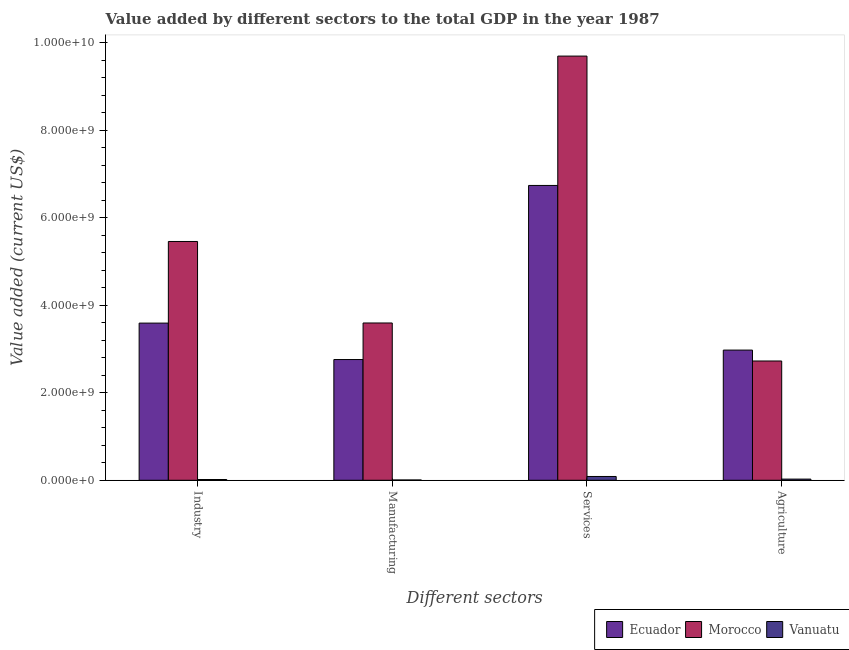How many different coloured bars are there?
Give a very brief answer. 3. How many groups of bars are there?
Keep it short and to the point. 4. Are the number of bars per tick equal to the number of legend labels?
Make the answer very short. Yes. How many bars are there on the 3rd tick from the right?
Keep it short and to the point. 3. What is the label of the 4th group of bars from the left?
Provide a succinct answer. Agriculture. What is the value added by agricultural sector in Vanuatu?
Give a very brief answer. 2.66e+07. Across all countries, what is the maximum value added by agricultural sector?
Provide a short and direct response. 2.98e+09. Across all countries, what is the minimum value added by manufacturing sector?
Make the answer very short. 6.66e+06. In which country was the value added by manufacturing sector maximum?
Provide a succinct answer. Morocco. In which country was the value added by services sector minimum?
Provide a short and direct response. Vanuatu. What is the total value added by manufacturing sector in the graph?
Offer a very short reply. 6.36e+09. What is the difference between the value added by industrial sector in Vanuatu and that in Ecuador?
Offer a terse response. -3.58e+09. What is the difference between the value added by manufacturing sector in Vanuatu and the value added by services sector in Ecuador?
Give a very brief answer. -6.74e+09. What is the average value added by services sector per country?
Your answer should be very brief. 5.51e+09. What is the difference between the value added by services sector and value added by manufacturing sector in Vanuatu?
Ensure brevity in your answer.  8.01e+07. What is the ratio of the value added by agricultural sector in Morocco to that in Vanuatu?
Your response must be concise. 102.37. Is the value added by services sector in Vanuatu less than that in Morocco?
Make the answer very short. Yes. What is the difference between the highest and the second highest value added by agricultural sector?
Ensure brevity in your answer.  2.49e+08. What is the difference between the highest and the lowest value added by agricultural sector?
Provide a succinct answer. 2.95e+09. In how many countries, is the value added by industrial sector greater than the average value added by industrial sector taken over all countries?
Your answer should be very brief. 2. Is the sum of the value added by services sector in Ecuador and Morocco greater than the maximum value added by manufacturing sector across all countries?
Your answer should be compact. Yes. Is it the case that in every country, the sum of the value added by services sector and value added by industrial sector is greater than the sum of value added by manufacturing sector and value added by agricultural sector?
Give a very brief answer. No. What does the 1st bar from the left in Services represents?
Make the answer very short. Ecuador. What does the 3rd bar from the right in Industry represents?
Your answer should be compact. Ecuador. How many bars are there?
Keep it short and to the point. 12. Are all the bars in the graph horizontal?
Your response must be concise. No. What is the difference between two consecutive major ticks on the Y-axis?
Offer a very short reply. 2.00e+09. Are the values on the major ticks of Y-axis written in scientific E-notation?
Your answer should be very brief. Yes. Where does the legend appear in the graph?
Give a very brief answer. Bottom right. How many legend labels are there?
Your answer should be very brief. 3. What is the title of the graph?
Make the answer very short. Value added by different sectors to the total GDP in the year 1987. What is the label or title of the X-axis?
Offer a terse response. Different sectors. What is the label or title of the Y-axis?
Provide a short and direct response. Value added (current US$). What is the Value added (current US$) in Ecuador in Industry?
Offer a terse response. 3.59e+09. What is the Value added (current US$) in Morocco in Industry?
Provide a succinct answer. 5.46e+09. What is the Value added (current US$) in Vanuatu in Industry?
Offer a very short reply. 1.75e+07. What is the Value added (current US$) in Ecuador in Manufacturing?
Offer a very short reply. 2.76e+09. What is the Value added (current US$) in Morocco in Manufacturing?
Provide a succinct answer. 3.60e+09. What is the Value added (current US$) in Vanuatu in Manufacturing?
Your answer should be compact. 6.66e+06. What is the Value added (current US$) in Ecuador in Services?
Provide a short and direct response. 6.74e+09. What is the Value added (current US$) in Morocco in Services?
Give a very brief answer. 9.70e+09. What is the Value added (current US$) of Vanuatu in Services?
Provide a short and direct response. 8.67e+07. What is the Value added (current US$) in Ecuador in Agriculture?
Provide a succinct answer. 2.98e+09. What is the Value added (current US$) in Morocco in Agriculture?
Provide a short and direct response. 2.73e+09. What is the Value added (current US$) of Vanuatu in Agriculture?
Offer a very short reply. 2.66e+07. Across all Different sectors, what is the maximum Value added (current US$) of Ecuador?
Provide a succinct answer. 6.74e+09. Across all Different sectors, what is the maximum Value added (current US$) in Morocco?
Give a very brief answer. 9.70e+09. Across all Different sectors, what is the maximum Value added (current US$) in Vanuatu?
Provide a succinct answer. 8.67e+07. Across all Different sectors, what is the minimum Value added (current US$) of Ecuador?
Keep it short and to the point. 2.76e+09. Across all Different sectors, what is the minimum Value added (current US$) in Morocco?
Give a very brief answer. 2.73e+09. Across all Different sectors, what is the minimum Value added (current US$) of Vanuatu?
Ensure brevity in your answer.  6.66e+06. What is the total Value added (current US$) in Ecuador in the graph?
Keep it short and to the point. 1.61e+1. What is the total Value added (current US$) of Morocco in the graph?
Keep it short and to the point. 2.15e+1. What is the total Value added (current US$) of Vanuatu in the graph?
Keep it short and to the point. 1.37e+08. What is the difference between the Value added (current US$) of Ecuador in Industry and that in Manufacturing?
Give a very brief answer. 8.33e+08. What is the difference between the Value added (current US$) of Morocco in Industry and that in Manufacturing?
Offer a very short reply. 1.86e+09. What is the difference between the Value added (current US$) in Vanuatu in Industry and that in Manufacturing?
Offer a very short reply. 1.08e+07. What is the difference between the Value added (current US$) in Ecuador in Industry and that in Services?
Your response must be concise. -3.15e+09. What is the difference between the Value added (current US$) in Morocco in Industry and that in Services?
Ensure brevity in your answer.  -4.24e+09. What is the difference between the Value added (current US$) of Vanuatu in Industry and that in Services?
Ensure brevity in your answer.  -6.93e+07. What is the difference between the Value added (current US$) in Ecuador in Industry and that in Agriculture?
Offer a very short reply. 6.17e+08. What is the difference between the Value added (current US$) of Morocco in Industry and that in Agriculture?
Your response must be concise. 2.73e+09. What is the difference between the Value added (current US$) in Vanuatu in Industry and that in Agriculture?
Provide a short and direct response. -9.19e+06. What is the difference between the Value added (current US$) in Ecuador in Manufacturing and that in Services?
Your response must be concise. -3.98e+09. What is the difference between the Value added (current US$) in Morocco in Manufacturing and that in Services?
Your answer should be very brief. -6.10e+09. What is the difference between the Value added (current US$) in Vanuatu in Manufacturing and that in Services?
Offer a terse response. -8.01e+07. What is the difference between the Value added (current US$) of Ecuador in Manufacturing and that in Agriculture?
Give a very brief answer. -2.16e+08. What is the difference between the Value added (current US$) in Morocco in Manufacturing and that in Agriculture?
Ensure brevity in your answer.  8.69e+08. What is the difference between the Value added (current US$) of Vanuatu in Manufacturing and that in Agriculture?
Keep it short and to the point. -2.00e+07. What is the difference between the Value added (current US$) of Ecuador in Services and that in Agriculture?
Ensure brevity in your answer.  3.76e+09. What is the difference between the Value added (current US$) in Morocco in Services and that in Agriculture?
Your answer should be very brief. 6.97e+09. What is the difference between the Value added (current US$) in Vanuatu in Services and that in Agriculture?
Provide a succinct answer. 6.01e+07. What is the difference between the Value added (current US$) in Ecuador in Industry and the Value added (current US$) in Morocco in Manufacturing?
Make the answer very short. -2.68e+06. What is the difference between the Value added (current US$) in Ecuador in Industry and the Value added (current US$) in Vanuatu in Manufacturing?
Offer a very short reply. 3.59e+09. What is the difference between the Value added (current US$) of Morocco in Industry and the Value added (current US$) of Vanuatu in Manufacturing?
Your response must be concise. 5.45e+09. What is the difference between the Value added (current US$) in Ecuador in Industry and the Value added (current US$) in Morocco in Services?
Offer a terse response. -6.11e+09. What is the difference between the Value added (current US$) of Ecuador in Industry and the Value added (current US$) of Vanuatu in Services?
Ensure brevity in your answer.  3.51e+09. What is the difference between the Value added (current US$) of Morocco in Industry and the Value added (current US$) of Vanuatu in Services?
Your answer should be compact. 5.37e+09. What is the difference between the Value added (current US$) in Ecuador in Industry and the Value added (current US$) in Morocco in Agriculture?
Provide a succinct answer. 8.66e+08. What is the difference between the Value added (current US$) in Ecuador in Industry and the Value added (current US$) in Vanuatu in Agriculture?
Give a very brief answer. 3.57e+09. What is the difference between the Value added (current US$) of Morocco in Industry and the Value added (current US$) of Vanuatu in Agriculture?
Ensure brevity in your answer.  5.43e+09. What is the difference between the Value added (current US$) of Ecuador in Manufacturing and the Value added (current US$) of Morocco in Services?
Keep it short and to the point. -6.94e+09. What is the difference between the Value added (current US$) of Ecuador in Manufacturing and the Value added (current US$) of Vanuatu in Services?
Your response must be concise. 2.67e+09. What is the difference between the Value added (current US$) in Morocco in Manufacturing and the Value added (current US$) in Vanuatu in Services?
Make the answer very short. 3.51e+09. What is the difference between the Value added (current US$) in Ecuador in Manufacturing and the Value added (current US$) in Morocco in Agriculture?
Offer a very short reply. 3.31e+07. What is the difference between the Value added (current US$) of Ecuador in Manufacturing and the Value added (current US$) of Vanuatu in Agriculture?
Provide a short and direct response. 2.73e+09. What is the difference between the Value added (current US$) in Morocco in Manufacturing and the Value added (current US$) in Vanuatu in Agriculture?
Your answer should be very brief. 3.57e+09. What is the difference between the Value added (current US$) in Ecuador in Services and the Value added (current US$) in Morocco in Agriculture?
Offer a terse response. 4.01e+09. What is the difference between the Value added (current US$) in Ecuador in Services and the Value added (current US$) in Vanuatu in Agriculture?
Ensure brevity in your answer.  6.72e+09. What is the difference between the Value added (current US$) in Morocco in Services and the Value added (current US$) in Vanuatu in Agriculture?
Your answer should be compact. 9.67e+09. What is the average Value added (current US$) of Ecuador per Different sectors?
Make the answer very short. 4.02e+09. What is the average Value added (current US$) of Morocco per Different sectors?
Keep it short and to the point. 5.37e+09. What is the average Value added (current US$) of Vanuatu per Different sectors?
Give a very brief answer. 3.44e+07. What is the difference between the Value added (current US$) of Ecuador and Value added (current US$) of Morocco in Industry?
Ensure brevity in your answer.  -1.87e+09. What is the difference between the Value added (current US$) of Ecuador and Value added (current US$) of Vanuatu in Industry?
Your answer should be very brief. 3.58e+09. What is the difference between the Value added (current US$) in Morocco and Value added (current US$) in Vanuatu in Industry?
Offer a very short reply. 5.44e+09. What is the difference between the Value added (current US$) of Ecuador and Value added (current US$) of Morocco in Manufacturing?
Offer a very short reply. -8.36e+08. What is the difference between the Value added (current US$) of Ecuador and Value added (current US$) of Vanuatu in Manufacturing?
Your response must be concise. 2.75e+09. What is the difference between the Value added (current US$) of Morocco and Value added (current US$) of Vanuatu in Manufacturing?
Keep it short and to the point. 3.59e+09. What is the difference between the Value added (current US$) of Ecuador and Value added (current US$) of Morocco in Services?
Your answer should be compact. -2.96e+09. What is the difference between the Value added (current US$) of Ecuador and Value added (current US$) of Vanuatu in Services?
Your answer should be compact. 6.66e+09. What is the difference between the Value added (current US$) of Morocco and Value added (current US$) of Vanuatu in Services?
Provide a succinct answer. 9.61e+09. What is the difference between the Value added (current US$) of Ecuador and Value added (current US$) of Morocco in Agriculture?
Your answer should be compact. 2.49e+08. What is the difference between the Value added (current US$) of Ecuador and Value added (current US$) of Vanuatu in Agriculture?
Provide a succinct answer. 2.95e+09. What is the difference between the Value added (current US$) of Morocco and Value added (current US$) of Vanuatu in Agriculture?
Give a very brief answer. 2.70e+09. What is the ratio of the Value added (current US$) of Ecuador in Industry to that in Manufacturing?
Give a very brief answer. 1.3. What is the ratio of the Value added (current US$) in Morocco in Industry to that in Manufacturing?
Provide a short and direct response. 1.52. What is the ratio of the Value added (current US$) of Vanuatu in Industry to that in Manufacturing?
Ensure brevity in your answer.  2.62. What is the ratio of the Value added (current US$) of Ecuador in Industry to that in Services?
Keep it short and to the point. 0.53. What is the ratio of the Value added (current US$) in Morocco in Industry to that in Services?
Your response must be concise. 0.56. What is the ratio of the Value added (current US$) in Vanuatu in Industry to that in Services?
Keep it short and to the point. 0.2. What is the ratio of the Value added (current US$) of Ecuador in Industry to that in Agriculture?
Offer a terse response. 1.21. What is the ratio of the Value added (current US$) of Morocco in Industry to that in Agriculture?
Make the answer very short. 2. What is the ratio of the Value added (current US$) in Vanuatu in Industry to that in Agriculture?
Your answer should be compact. 0.66. What is the ratio of the Value added (current US$) in Ecuador in Manufacturing to that in Services?
Offer a terse response. 0.41. What is the ratio of the Value added (current US$) of Morocco in Manufacturing to that in Services?
Your answer should be very brief. 0.37. What is the ratio of the Value added (current US$) of Vanuatu in Manufacturing to that in Services?
Your response must be concise. 0.08. What is the ratio of the Value added (current US$) in Ecuador in Manufacturing to that in Agriculture?
Your answer should be very brief. 0.93. What is the ratio of the Value added (current US$) in Morocco in Manufacturing to that in Agriculture?
Offer a very short reply. 1.32. What is the ratio of the Value added (current US$) of Vanuatu in Manufacturing to that in Agriculture?
Offer a terse response. 0.25. What is the ratio of the Value added (current US$) of Ecuador in Services to that in Agriculture?
Provide a succinct answer. 2.26. What is the ratio of the Value added (current US$) of Morocco in Services to that in Agriculture?
Provide a short and direct response. 3.56. What is the ratio of the Value added (current US$) of Vanuatu in Services to that in Agriculture?
Your answer should be very brief. 3.25. What is the difference between the highest and the second highest Value added (current US$) of Ecuador?
Give a very brief answer. 3.15e+09. What is the difference between the highest and the second highest Value added (current US$) of Morocco?
Make the answer very short. 4.24e+09. What is the difference between the highest and the second highest Value added (current US$) of Vanuatu?
Offer a terse response. 6.01e+07. What is the difference between the highest and the lowest Value added (current US$) in Ecuador?
Your answer should be compact. 3.98e+09. What is the difference between the highest and the lowest Value added (current US$) in Morocco?
Make the answer very short. 6.97e+09. What is the difference between the highest and the lowest Value added (current US$) of Vanuatu?
Your answer should be compact. 8.01e+07. 